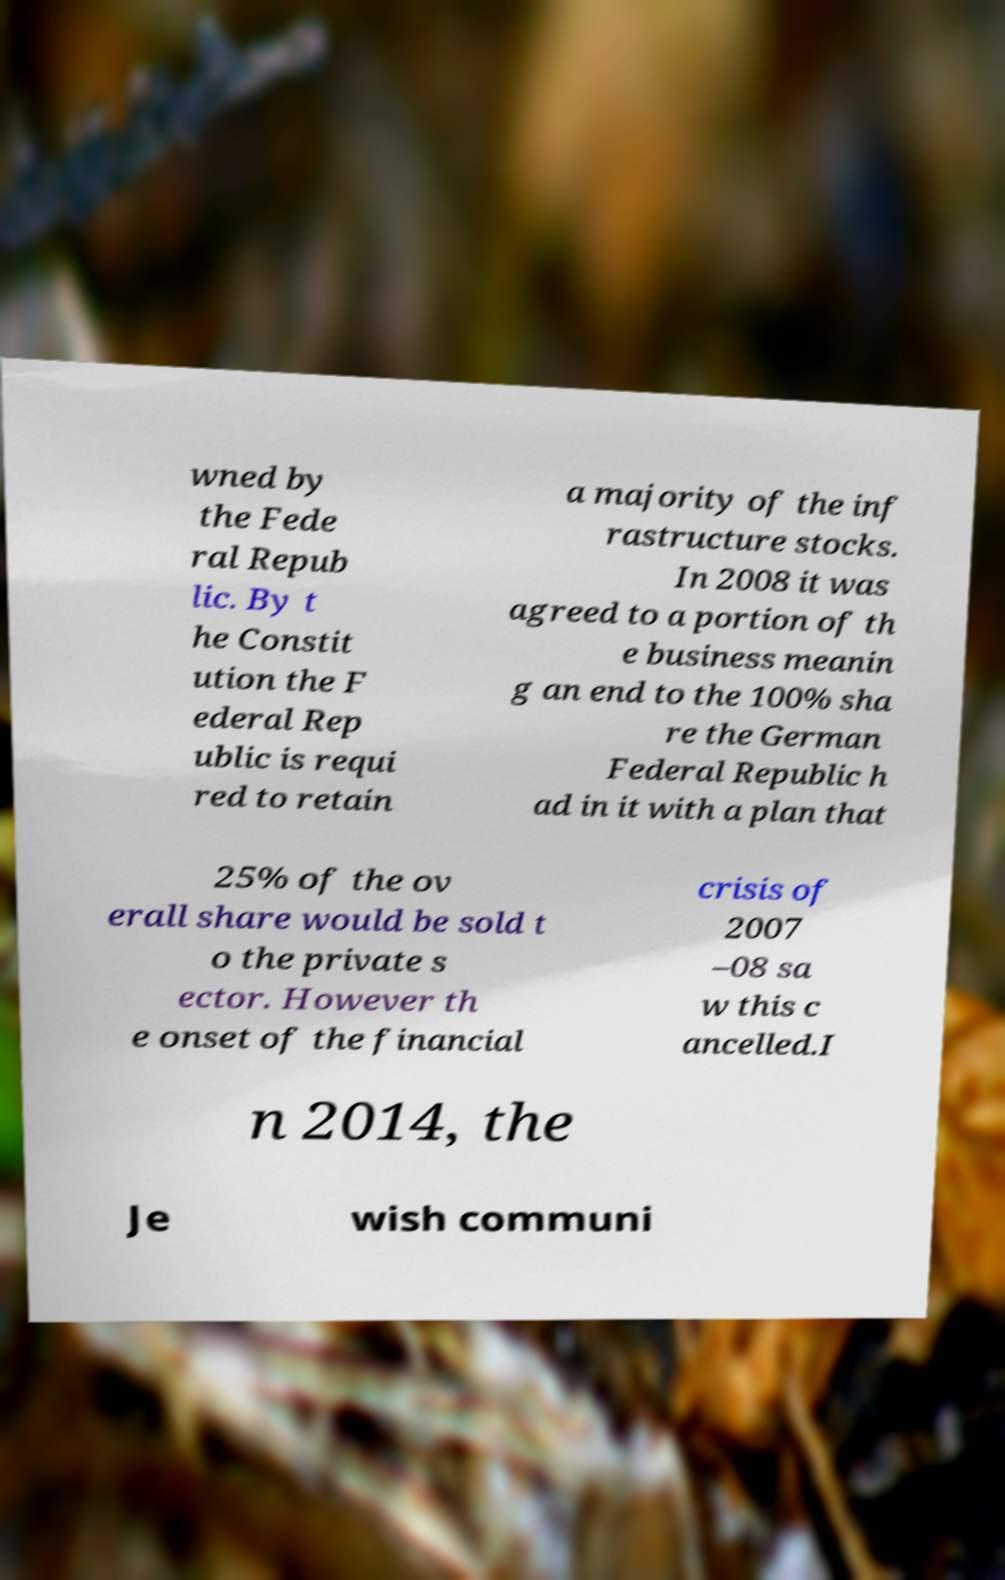Can you accurately transcribe the text from the provided image for me? wned by the Fede ral Repub lic. By t he Constit ution the F ederal Rep ublic is requi red to retain a majority of the inf rastructure stocks. In 2008 it was agreed to a portion of th e business meanin g an end to the 100% sha re the German Federal Republic h ad in it with a plan that 25% of the ov erall share would be sold t o the private s ector. However th e onset of the financial crisis of 2007 –08 sa w this c ancelled.I n 2014, the Je wish communi 